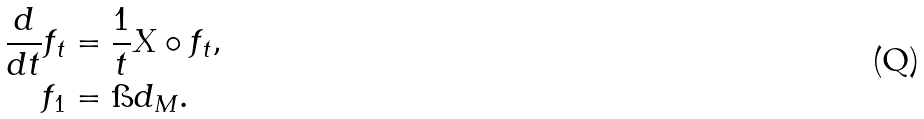Convert formula to latex. <formula><loc_0><loc_0><loc_500><loc_500>\frac { d } { d t } f _ { t } & = \frac { 1 } { t } X \circ f _ { t } , \\ f _ { 1 } & = \i d _ { M } .</formula> 